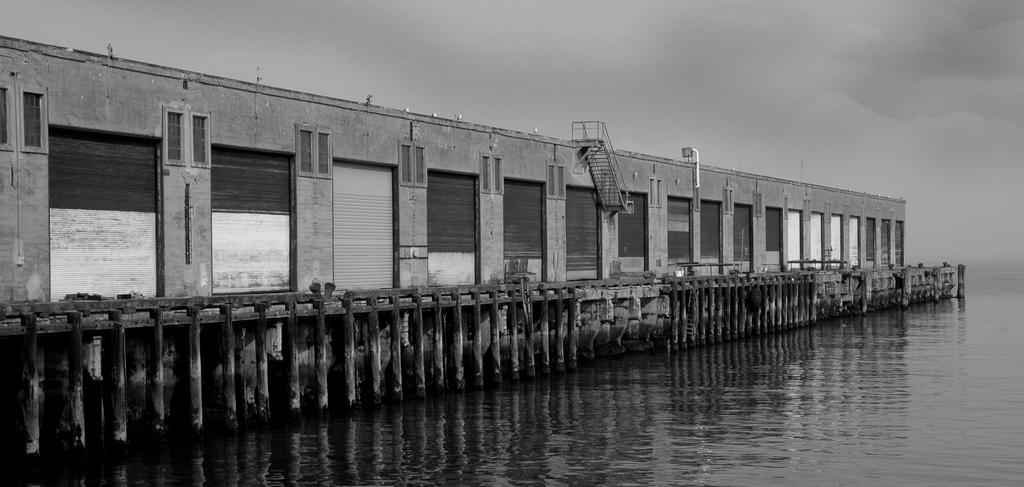What is the main subject in the center of the image? There are tide gates in the center of the image. What can be seen at the bottom of the image? There is water at the bottom of the image. What is visible in the background of the image? The sky is visible in the background of the image. Can you see a snail crawling on the tide gates in the image? There is no snail present on the tide gates in the image. Is there a coast visible in the image? The image does not show a coast; it primarily features tide gates and water. 